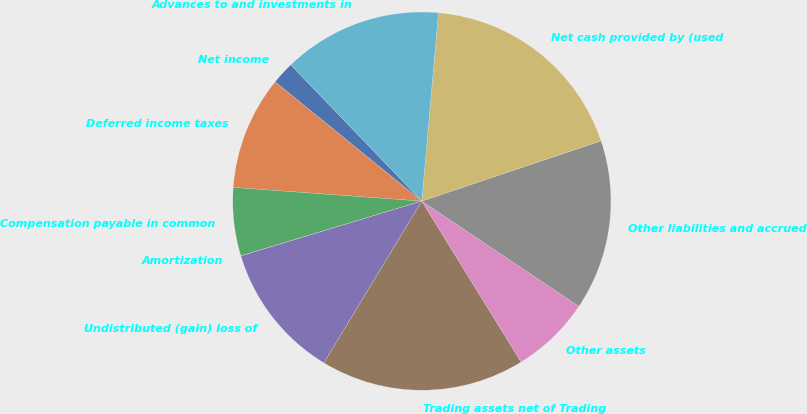Convert chart. <chart><loc_0><loc_0><loc_500><loc_500><pie_chart><fcel>Net income<fcel>Deferred income taxes<fcel>Compensation payable in common<fcel>Amortization<fcel>Undistributed (gain) loss of<fcel>Trading assets net of Trading<fcel>Other assets<fcel>Other liabilities and accrued<fcel>Net cash provided by (used<fcel>Advances to and investments in<nl><fcel>1.95%<fcel>9.71%<fcel>5.83%<fcel>0.01%<fcel>11.65%<fcel>17.47%<fcel>6.8%<fcel>14.56%<fcel>18.44%<fcel>13.59%<nl></chart> 